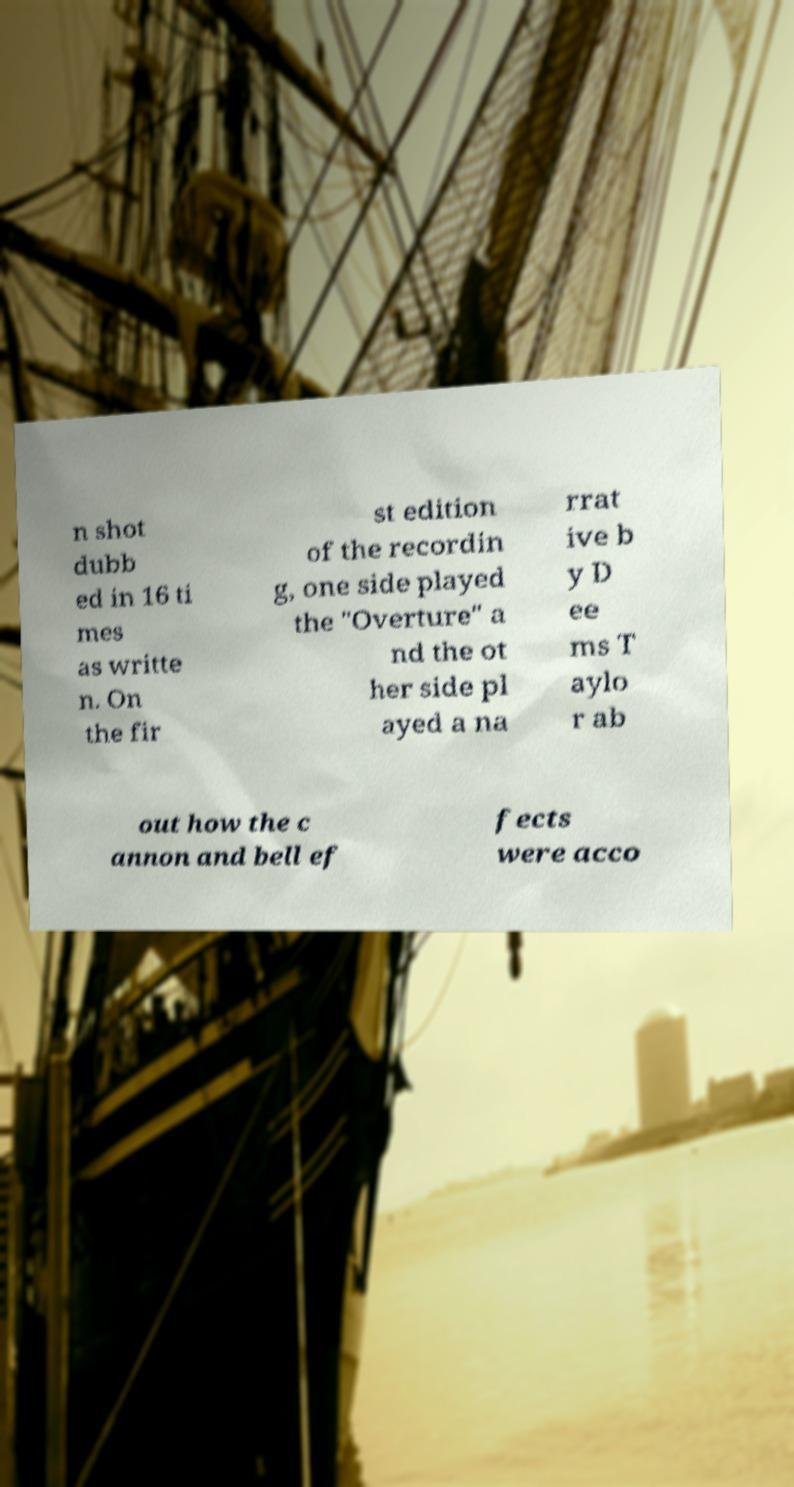Can you accurately transcribe the text from the provided image for me? n shot dubb ed in 16 ti mes as writte n. On the fir st edition of the recordin g, one side played the "Overture" a nd the ot her side pl ayed a na rrat ive b y D ee ms T aylo r ab out how the c annon and bell ef fects were acco 